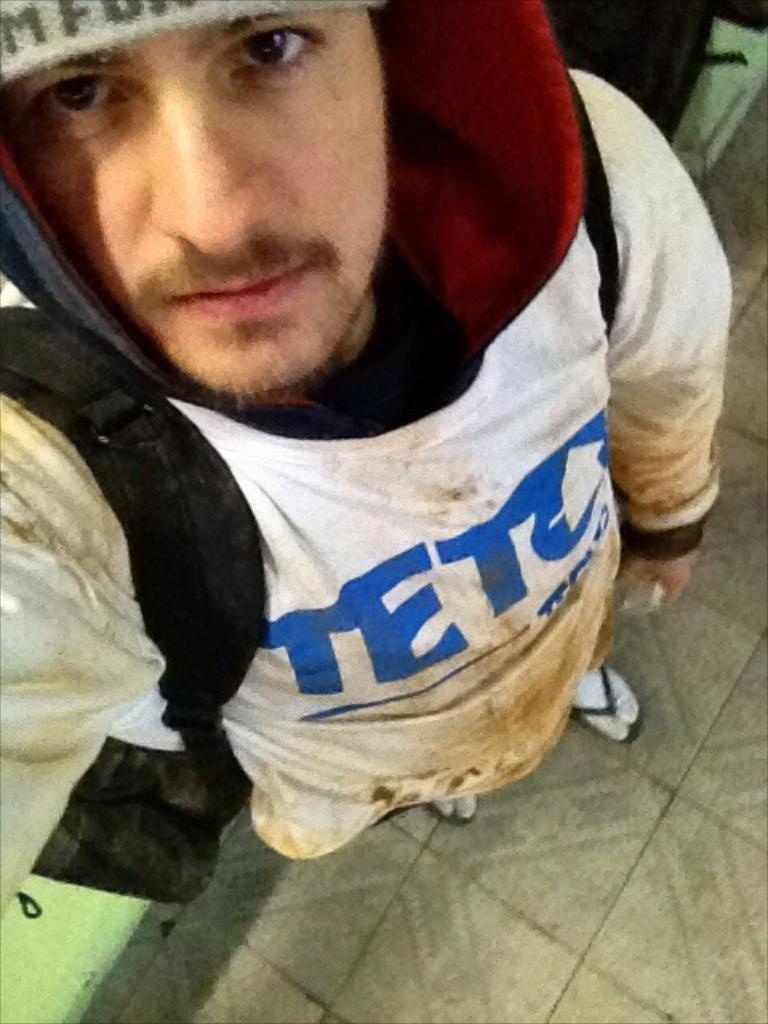<image>
Give a short and clear explanation of the subsequent image. a person with a teto shirt on themselves 